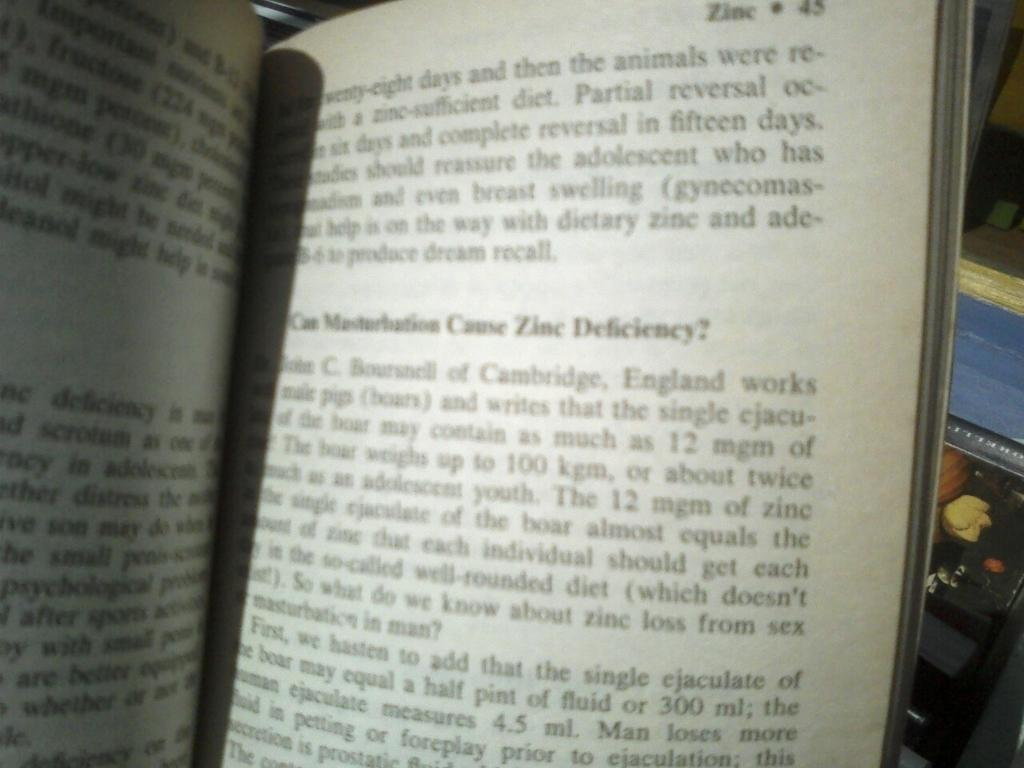<image>
Write a terse but informative summary of the picture. A book that is open to written text with on one page state Can Masturbation Cause Zinc Deficiency. 